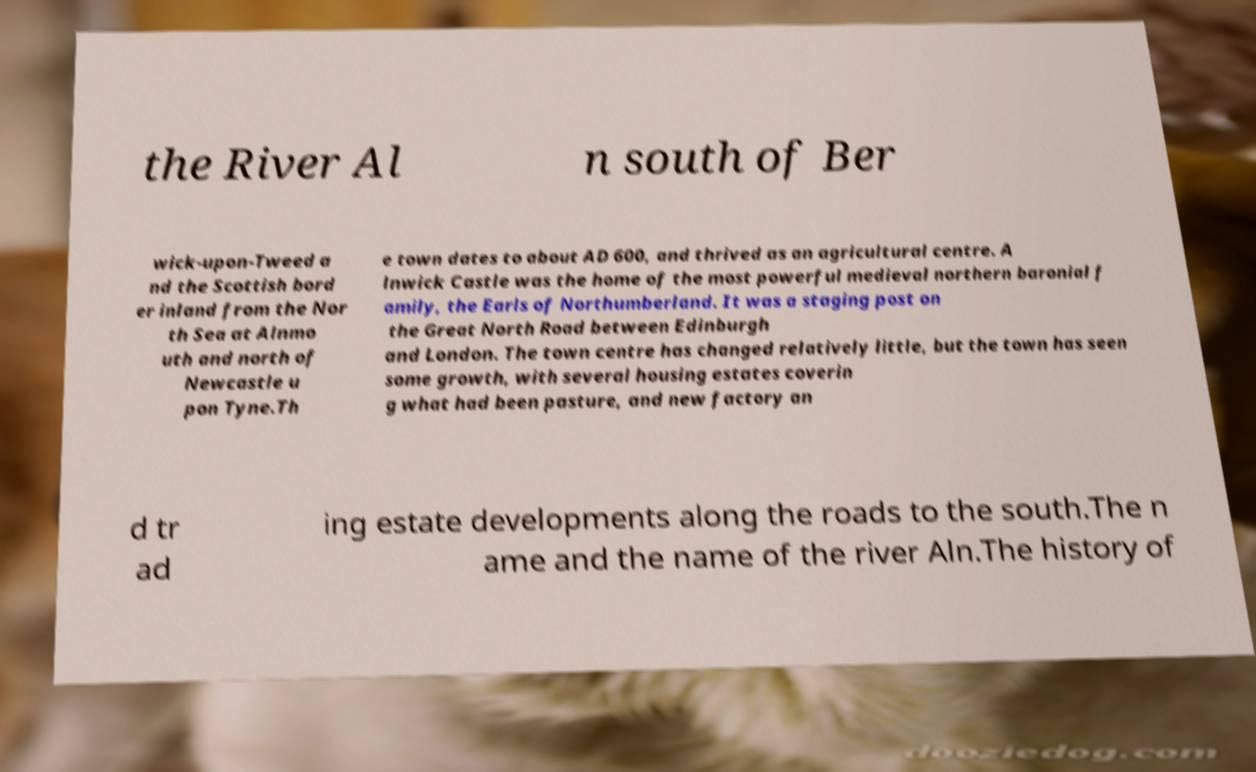Could you extract and type out the text from this image? the River Al n south of Ber wick-upon-Tweed a nd the Scottish bord er inland from the Nor th Sea at Alnmo uth and north of Newcastle u pon Tyne.Th e town dates to about AD 600, and thrived as an agricultural centre. A lnwick Castle was the home of the most powerful medieval northern baronial f amily, the Earls of Northumberland. It was a staging post on the Great North Road between Edinburgh and London. The town centre has changed relatively little, but the town has seen some growth, with several housing estates coverin g what had been pasture, and new factory an d tr ad ing estate developments along the roads to the south.The n ame and the name of the river Aln.The history of 